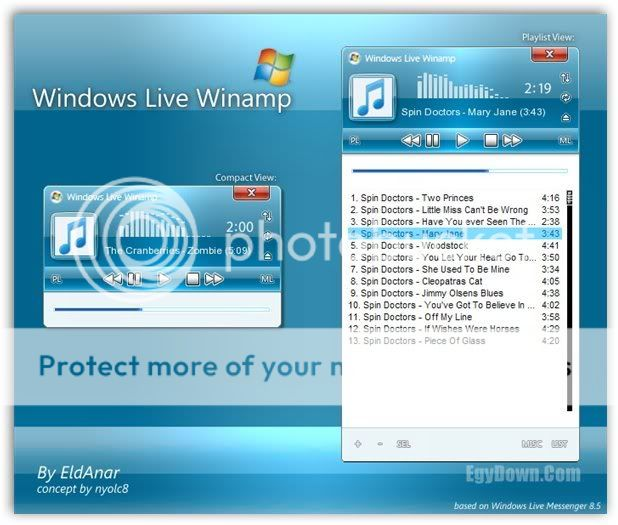Explain the significance of the 'Playlist View' section in context to this specific interface. The 'Playlist View' section of the media player serves a crucial role in enhancing the user's music experience. It allows users to see a list of tracks queued up for playing, enabling them to anticipate what is next or make changes as desired. In this specific interface, the 'Playlist View' is directly adjacent to the main player control, making it easy to manage the two simultaneously. Users can actively select, reorder, or remove tracks without navigating away from the main viewing window. Highlighted tracks and a scrollbar also improve accessibility, enabling users to manage large collections of music efficiently. 